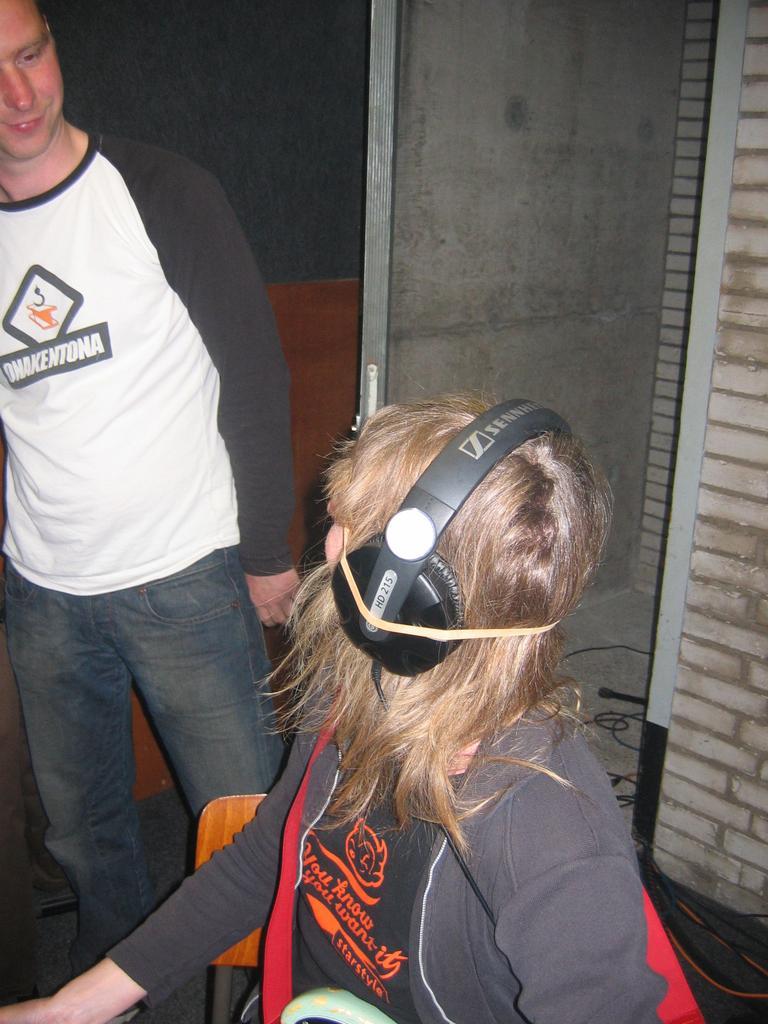How would you summarize this image in a sentence or two? Here I can see a person wearing a jacket, headset, sitting on a chair and looking at the man who is standing on the left side. In the background there is a door to the wall. 